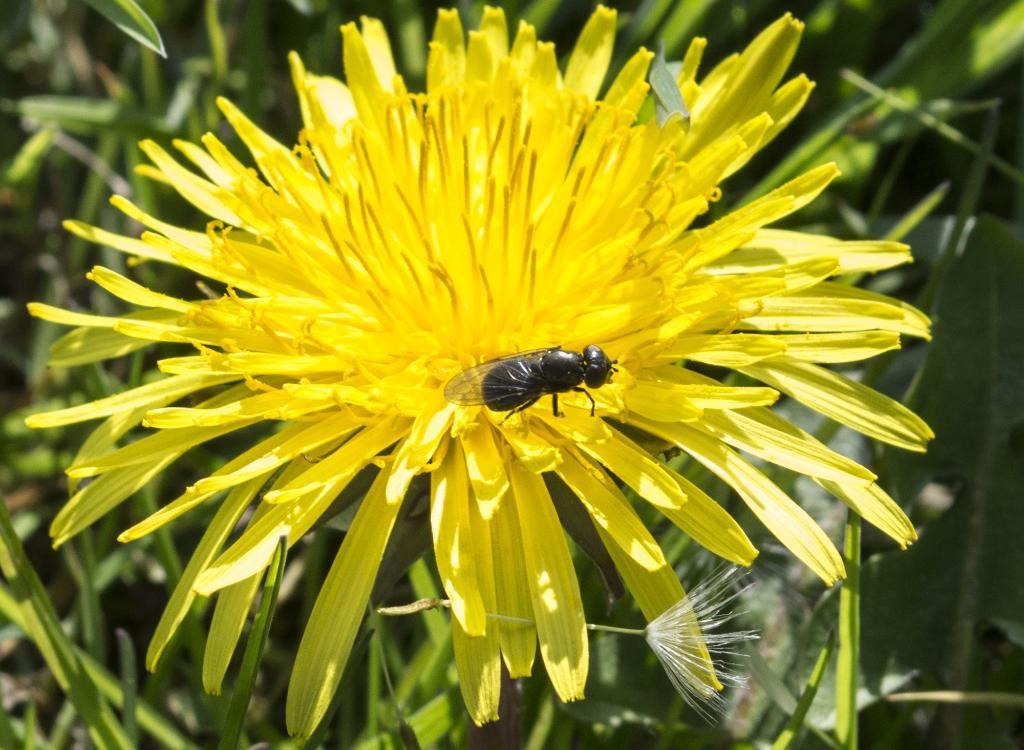What is there is a flower in the foreground of the picture, can you describe it? Yes, there is a flower in the foreground of the picture. Is there anything on the flower? Yes, there is a fly on the flower. What can be seen in the background of the picture? There is greenery in the background of the picture. What type of wire is being used to soothe the fly's throat in the image? There is no wire or throat mentioned in the image; it features a flower with a fly on it and greenery in the background. 